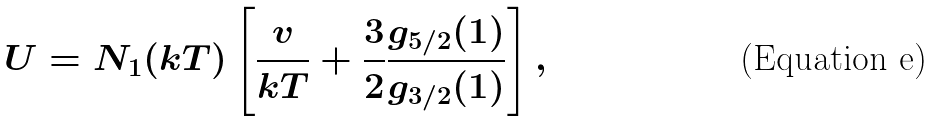Convert formula to latex. <formula><loc_0><loc_0><loc_500><loc_500>U = N _ { 1 } ( k T ) \left [ \frac { v } { k T } + \frac { 3 } { 2 } \frac { g _ { 5 / 2 } ( 1 ) } { g _ { 3 / 2 } ( 1 ) } \right ] ,</formula> 